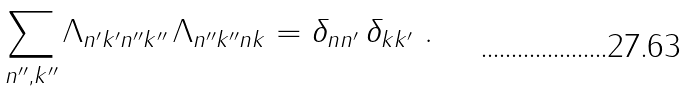Convert formula to latex. <formula><loc_0><loc_0><loc_500><loc_500>\sum _ { n ^ { \prime \prime } , k ^ { \prime \prime } } \Lambda _ { n ^ { \prime } k ^ { \prime } n ^ { \prime \prime } k ^ { \prime \prime } } \, \Lambda _ { n ^ { \prime \prime } k ^ { \prime \prime } n k } = \delta _ { n n ^ { \prime } } \, \delta _ { k k ^ { \prime } } \ .</formula> 